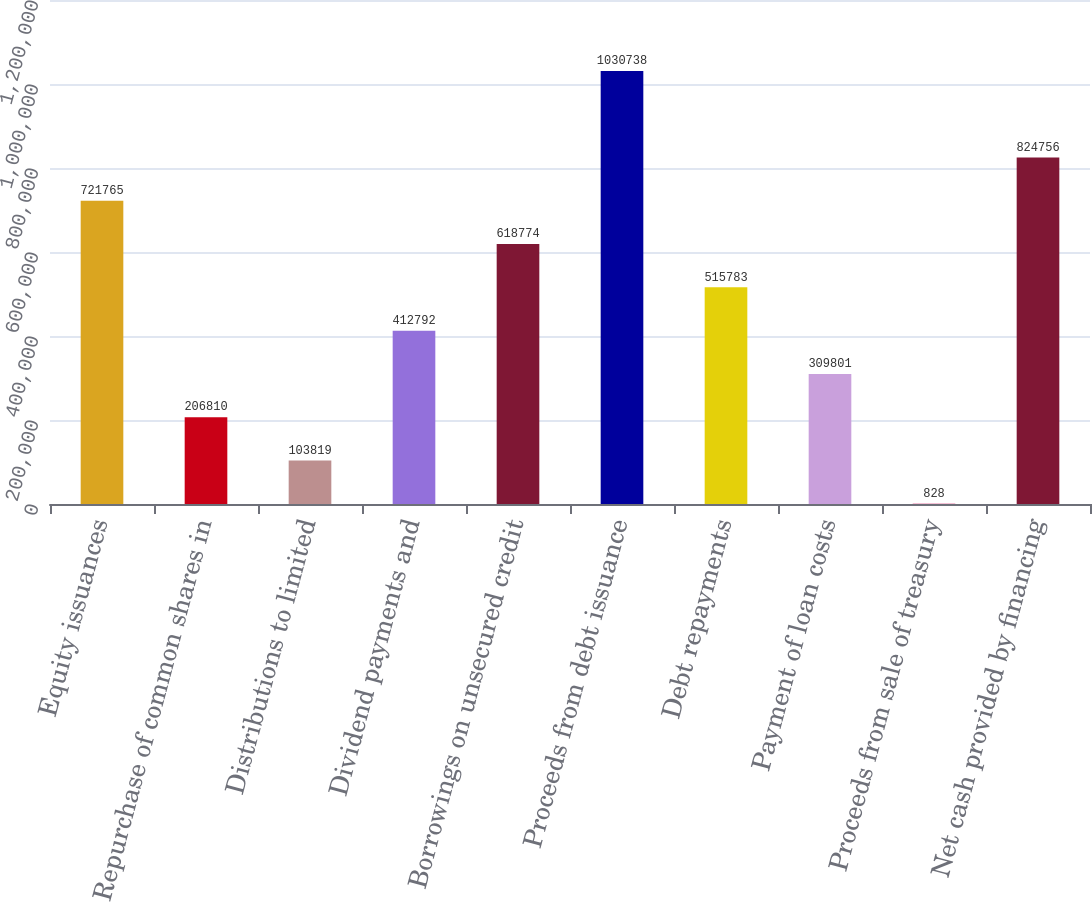<chart> <loc_0><loc_0><loc_500><loc_500><bar_chart><fcel>Equity issuances<fcel>Repurchase of common shares in<fcel>Distributions to limited<fcel>Dividend payments and<fcel>Borrowings on unsecured credit<fcel>Proceeds from debt issuance<fcel>Debt repayments<fcel>Payment of loan costs<fcel>Proceeds from sale of treasury<fcel>Net cash provided by financing<nl><fcel>721765<fcel>206810<fcel>103819<fcel>412792<fcel>618774<fcel>1.03074e+06<fcel>515783<fcel>309801<fcel>828<fcel>824756<nl></chart> 